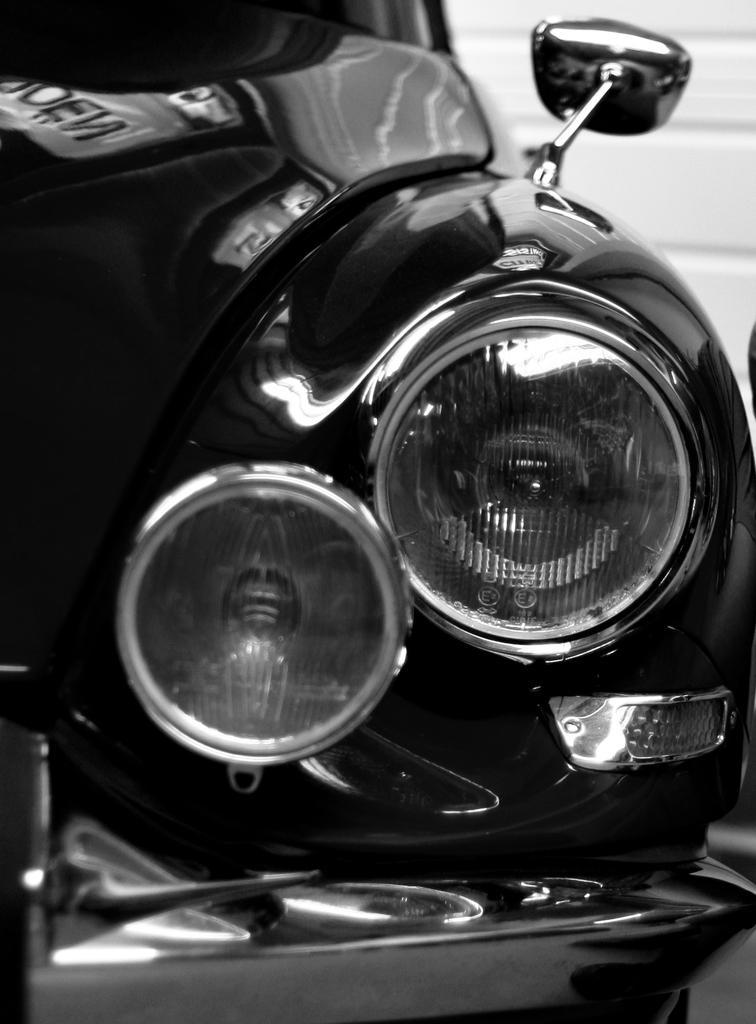What is the main subject of the picture? The main subject of the picture is a car. What specific features can be seen on the car? The car has headlights, a front bumper, and a side mirror. What is visible in the background of the picture? There is a wall in the background of the picture. What type of dress is the car wearing in the image? Cars do not wear dresses, as they are inanimate objects. 